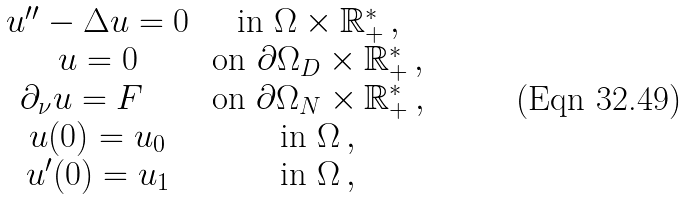Convert formula to latex. <formula><loc_0><loc_0><loc_500><loc_500>\begin{matrix} u ^ { \prime \prime } - \Delta u = 0 \, & \text {in } \Omega \times \mathbb { R } ^ { * } _ { + } \, , \\ u = 0 \, & \text {on } \partial \Omega _ { D } \times \mathbb { R } ^ { * } _ { + } \, , \\ \partial _ { \nu } u = F \, \quad & \text {on } \partial \Omega _ { N } \times \mathbb { R } ^ { * } _ { + } \, , \\ u ( 0 ) = u _ { 0 } \, & \text {in } \Omega \, , \\ u ^ { \prime } ( 0 ) = u _ { 1 } \, & \text {in } \Omega \, , \end{matrix}</formula> 